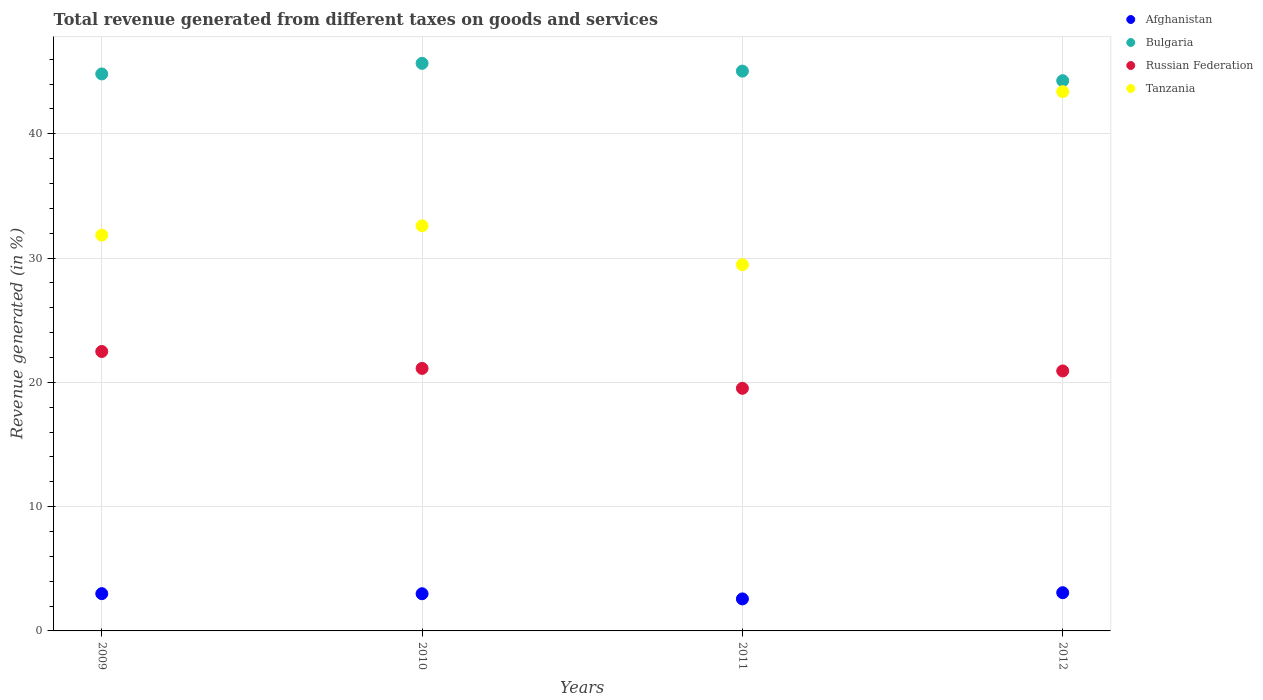Is the number of dotlines equal to the number of legend labels?
Provide a short and direct response. Yes. What is the total revenue generated in Russian Federation in 2010?
Your answer should be very brief. 21.12. Across all years, what is the maximum total revenue generated in Bulgaria?
Your response must be concise. 45.67. Across all years, what is the minimum total revenue generated in Russian Federation?
Provide a short and direct response. 19.52. In which year was the total revenue generated in Bulgaria maximum?
Your answer should be very brief. 2010. In which year was the total revenue generated in Tanzania minimum?
Ensure brevity in your answer.  2011. What is the total total revenue generated in Russian Federation in the graph?
Ensure brevity in your answer.  84.04. What is the difference between the total revenue generated in Afghanistan in 2010 and that in 2012?
Make the answer very short. -0.08. What is the difference between the total revenue generated in Russian Federation in 2011 and the total revenue generated in Tanzania in 2009?
Your answer should be compact. -12.33. What is the average total revenue generated in Russian Federation per year?
Provide a short and direct response. 21.01. In the year 2011, what is the difference between the total revenue generated in Tanzania and total revenue generated in Russian Federation?
Your response must be concise. 9.94. In how many years, is the total revenue generated in Bulgaria greater than 24 %?
Provide a succinct answer. 4. What is the ratio of the total revenue generated in Tanzania in 2010 to that in 2011?
Keep it short and to the point. 1.11. Is the difference between the total revenue generated in Tanzania in 2010 and 2011 greater than the difference between the total revenue generated in Russian Federation in 2010 and 2011?
Your response must be concise. Yes. What is the difference between the highest and the second highest total revenue generated in Tanzania?
Provide a succinct answer. 10.79. What is the difference between the highest and the lowest total revenue generated in Russian Federation?
Provide a succinct answer. 2.96. Is the sum of the total revenue generated in Tanzania in 2009 and 2011 greater than the maximum total revenue generated in Russian Federation across all years?
Ensure brevity in your answer.  Yes. Is it the case that in every year, the sum of the total revenue generated in Bulgaria and total revenue generated in Afghanistan  is greater than the sum of total revenue generated in Tanzania and total revenue generated in Russian Federation?
Your answer should be very brief. Yes. Is it the case that in every year, the sum of the total revenue generated in Bulgaria and total revenue generated in Russian Federation  is greater than the total revenue generated in Afghanistan?
Your response must be concise. Yes. Are the values on the major ticks of Y-axis written in scientific E-notation?
Offer a very short reply. No. Does the graph contain grids?
Offer a terse response. Yes. Where does the legend appear in the graph?
Provide a succinct answer. Top right. How are the legend labels stacked?
Give a very brief answer. Vertical. What is the title of the graph?
Give a very brief answer. Total revenue generated from different taxes on goods and services. What is the label or title of the Y-axis?
Your answer should be compact. Revenue generated (in %). What is the Revenue generated (in %) of Afghanistan in 2009?
Offer a very short reply. 3. What is the Revenue generated (in %) of Bulgaria in 2009?
Offer a very short reply. 44.81. What is the Revenue generated (in %) of Russian Federation in 2009?
Your answer should be compact. 22.48. What is the Revenue generated (in %) of Tanzania in 2009?
Provide a short and direct response. 31.85. What is the Revenue generated (in %) in Afghanistan in 2010?
Offer a very short reply. 2.99. What is the Revenue generated (in %) of Bulgaria in 2010?
Your response must be concise. 45.67. What is the Revenue generated (in %) in Russian Federation in 2010?
Provide a succinct answer. 21.12. What is the Revenue generated (in %) in Tanzania in 2010?
Your answer should be compact. 32.6. What is the Revenue generated (in %) in Afghanistan in 2011?
Provide a succinct answer. 2.58. What is the Revenue generated (in %) of Bulgaria in 2011?
Offer a terse response. 45.04. What is the Revenue generated (in %) in Russian Federation in 2011?
Provide a succinct answer. 19.52. What is the Revenue generated (in %) of Tanzania in 2011?
Give a very brief answer. 29.47. What is the Revenue generated (in %) of Afghanistan in 2012?
Your answer should be compact. 3.08. What is the Revenue generated (in %) in Bulgaria in 2012?
Provide a succinct answer. 44.27. What is the Revenue generated (in %) of Russian Federation in 2012?
Make the answer very short. 20.92. What is the Revenue generated (in %) of Tanzania in 2012?
Give a very brief answer. 43.39. Across all years, what is the maximum Revenue generated (in %) in Afghanistan?
Your response must be concise. 3.08. Across all years, what is the maximum Revenue generated (in %) of Bulgaria?
Your response must be concise. 45.67. Across all years, what is the maximum Revenue generated (in %) in Russian Federation?
Provide a short and direct response. 22.48. Across all years, what is the maximum Revenue generated (in %) in Tanzania?
Provide a short and direct response. 43.39. Across all years, what is the minimum Revenue generated (in %) of Afghanistan?
Make the answer very short. 2.58. Across all years, what is the minimum Revenue generated (in %) in Bulgaria?
Your answer should be compact. 44.27. Across all years, what is the minimum Revenue generated (in %) of Russian Federation?
Keep it short and to the point. 19.52. Across all years, what is the minimum Revenue generated (in %) in Tanzania?
Provide a succinct answer. 29.47. What is the total Revenue generated (in %) in Afghanistan in the graph?
Offer a terse response. 11.64. What is the total Revenue generated (in %) of Bulgaria in the graph?
Your answer should be very brief. 179.79. What is the total Revenue generated (in %) in Russian Federation in the graph?
Offer a very short reply. 84.04. What is the total Revenue generated (in %) in Tanzania in the graph?
Give a very brief answer. 137.3. What is the difference between the Revenue generated (in %) in Afghanistan in 2009 and that in 2010?
Give a very brief answer. 0.01. What is the difference between the Revenue generated (in %) in Bulgaria in 2009 and that in 2010?
Make the answer very short. -0.85. What is the difference between the Revenue generated (in %) in Russian Federation in 2009 and that in 2010?
Make the answer very short. 1.36. What is the difference between the Revenue generated (in %) in Tanzania in 2009 and that in 2010?
Your answer should be very brief. -0.75. What is the difference between the Revenue generated (in %) in Afghanistan in 2009 and that in 2011?
Give a very brief answer. 0.42. What is the difference between the Revenue generated (in %) of Bulgaria in 2009 and that in 2011?
Make the answer very short. -0.23. What is the difference between the Revenue generated (in %) of Russian Federation in 2009 and that in 2011?
Your answer should be compact. 2.96. What is the difference between the Revenue generated (in %) in Tanzania in 2009 and that in 2011?
Your answer should be very brief. 2.38. What is the difference between the Revenue generated (in %) in Afghanistan in 2009 and that in 2012?
Your response must be concise. -0.08. What is the difference between the Revenue generated (in %) of Bulgaria in 2009 and that in 2012?
Ensure brevity in your answer.  0.54. What is the difference between the Revenue generated (in %) of Russian Federation in 2009 and that in 2012?
Offer a very short reply. 1.56. What is the difference between the Revenue generated (in %) in Tanzania in 2009 and that in 2012?
Offer a terse response. -11.54. What is the difference between the Revenue generated (in %) of Afghanistan in 2010 and that in 2011?
Offer a terse response. 0.42. What is the difference between the Revenue generated (in %) of Bulgaria in 2010 and that in 2011?
Provide a short and direct response. 0.62. What is the difference between the Revenue generated (in %) of Russian Federation in 2010 and that in 2011?
Offer a terse response. 1.6. What is the difference between the Revenue generated (in %) of Tanzania in 2010 and that in 2011?
Make the answer very short. 3.13. What is the difference between the Revenue generated (in %) in Afghanistan in 2010 and that in 2012?
Offer a very short reply. -0.08. What is the difference between the Revenue generated (in %) of Bulgaria in 2010 and that in 2012?
Offer a very short reply. 1.4. What is the difference between the Revenue generated (in %) of Russian Federation in 2010 and that in 2012?
Give a very brief answer. 0.2. What is the difference between the Revenue generated (in %) in Tanzania in 2010 and that in 2012?
Offer a very short reply. -10.79. What is the difference between the Revenue generated (in %) in Afghanistan in 2011 and that in 2012?
Offer a terse response. -0.5. What is the difference between the Revenue generated (in %) in Bulgaria in 2011 and that in 2012?
Provide a succinct answer. 0.77. What is the difference between the Revenue generated (in %) of Russian Federation in 2011 and that in 2012?
Your answer should be compact. -1.4. What is the difference between the Revenue generated (in %) in Tanzania in 2011 and that in 2012?
Your answer should be very brief. -13.93. What is the difference between the Revenue generated (in %) of Afghanistan in 2009 and the Revenue generated (in %) of Bulgaria in 2010?
Ensure brevity in your answer.  -42.67. What is the difference between the Revenue generated (in %) in Afghanistan in 2009 and the Revenue generated (in %) in Russian Federation in 2010?
Your answer should be compact. -18.12. What is the difference between the Revenue generated (in %) of Afghanistan in 2009 and the Revenue generated (in %) of Tanzania in 2010?
Keep it short and to the point. -29.6. What is the difference between the Revenue generated (in %) in Bulgaria in 2009 and the Revenue generated (in %) in Russian Federation in 2010?
Your answer should be very brief. 23.69. What is the difference between the Revenue generated (in %) in Bulgaria in 2009 and the Revenue generated (in %) in Tanzania in 2010?
Offer a very short reply. 12.22. What is the difference between the Revenue generated (in %) of Russian Federation in 2009 and the Revenue generated (in %) of Tanzania in 2010?
Offer a terse response. -10.11. What is the difference between the Revenue generated (in %) of Afghanistan in 2009 and the Revenue generated (in %) of Bulgaria in 2011?
Keep it short and to the point. -42.04. What is the difference between the Revenue generated (in %) of Afghanistan in 2009 and the Revenue generated (in %) of Russian Federation in 2011?
Your answer should be compact. -16.52. What is the difference between the Revenue generated (in %) in Afghanistan in 2009 and the Revenue generated (in %) in Tanzania in 2011?
Offer a very short reply. -26.47. What is the difference between the Revenue generated (in %) in Bulgaria in 2009 and the Revenue generated (in %) in Russian Federation in 2011?
Keep it short and to the point. 25.29. What is the difference between the Revenue generated (in %) in Bulgaria in 2009 and the Revenue generated (in %) in Tanzania in 2011?
Offer a very short reply. 15.35. What is the difference between the Revenue generated (in %) in Russian Federation in 2009 and the Revenue generated (in %) in Tanzania in 2011?
Your response must be concise. -6.98. What is the difference between the Revenue generated (in %) in Afghanistan in 2009 and the Revenue generated (in %) in Bulgaria in 2012?
Offer a terse response. -41.27. What is the difference between the Revenue generated (in %) of Afghanistan in 2009 and the Revenue generated (in %) of Russian Federation in 2012?
Your response must be concise. -17.92. What is the difference between the Revenue generated (in %) of Afghanistan in 2009 and the Revenue generated (in %) of Tanzania in 2012?
Ensure brevity in your answer.  -40.39. What is the difference between the Revenue generated (in %) in Bulgaria in 2009 and the Revenue generated (in %) in Russian Federation in 2012?
Your answer should be very brief. 23.9. What is the difference between the Revenue generated (in %) in Bulgaria in 2009 and the Revenue generated (in %) in Tanzania in 2012?
Provide a short and direct response. 1.42. What is the difference between the Revenue generated (in %) of Russian Federation in 2009 and the Revenue generated (in %) of Tanzania in 2012?
Provide a succinct answer. -20.91. What is the difference between the Revenue generated (in %) in Afghanistan in 2010 and the Revenue generated (in %) in Bulgaria in 2011?
Give a very brief answer. -42.05. What is the difference between the Revenue generated (in %) of Afghanistan in 2010 and the Revenue generated (in %) of Russian Federation in 2011?
Keep it short and to the point. -16.53. What is the difference between the Revenue generated (in %) in Afghanistan in 2010 and the Revenue generated (in %) in Tanzania in 2011?
Make the answer very short. -26.47. What is the difference between the Revenue generated (in %) in Bulgaria in 2010 and the Revenue generated (in %) in Russian Federation in 2011?
Provide a short and direct response. 26.15. What is the difference between the Revenue generated (in %) in Bulgaria in 2010 and the Revenue generated (in %) in Tanzania in 2011?
Ensure brevity in your answer.  16.2. What is the difference between the Revenue generated (in %) of Russian Federation in 2010 and the Revenue generated (in %) of Tanzania in 2011?
Your response must be concise. -8.34. What is the difference between the Revenue generated (in %) in Afghanistan in 2010 and the Revenue generated (in %) in Bulgaria in 2012?
Make the answer very short. -41.28. What is the difference between the Revenue generated (in %) in Afghanistan in 2010 and the Revenue generated (in %) in Russian Federation in 2012?
Provide a short and direct response. -17.93. What is the difference between the Revenue generated (in %) in Afghanistan in 2010 and the Revenue generated (in %) in Tanzania in 2012?
Ensure brevity in your answer.  -40.4. What is the difference between the Revenue generated (in %) in Bulgaria in 2010 and the Revenue generated (in %) in Russian Federation in 2012?
Provide a succinct answer. 24.75. What is the difference between the Revenue generated (in %) in Bulgaria in 2010 and the Revenue generated (in %) in Tanzania in 2012?
Your answer should be very brief. 2.28. What is the difference between the Revenue generated (in %) of Russian Federation in 2010 and the Revenue generated (in %) of Tanzania in 2012?
Give a very brief answer. -22.27. What is the difference between the Revenue generated (in %) in Afghanistan in 2011 and the Revenue generated (in %) in Bulgaria in 2012?
Your answer should be very brief. -41.69. What is the difference between the Revenue generated (in %) in Afghanistan in 2011 and the Revenue generated (in %) in Russian Federation in 2012?
Offer a terse response. -18.34. What is the difference between the Revenue generated (in %) in Afghanistan in 2011 and the Revenue generated (in %) in Tanzania in 2012?
Offer a very short reply. -40.81. What is the difference between the Revenue generated (in %) in Bulgaria in 2011 and the Revenue generated (in %) in Russian Federation in 2012?
Your response must be concise. 24.12. What is the difference between the Revenue generated (in %) of Bulgaria in 2011 and the Revenue generated (in %) of Tanzania in 2012?
Ensure brevity in your answer.  1.65. What is the difference between the Revenue generated (in %) of Russian Federation in 2011 and the Revenue generated (in %) of Tanzania in 2012?
Ensure brevity in your answer.  -23.87. What is the average Revenue generated (in %) in Afghanistan per year?
Give a very brief answer. 2.91. What is the average Revenue generated (in %) of Bulgaria per year?
Make the answer very short. 44.95. What is the average Revenue generated (in %) in Russian Federation per year?
Your answer should be very brief. 21.01. What is the average Revenue generated (in %) of Tanzania per year?
Your response must be concise. 34.32. In the year 2009, what is the difference between the Revenue generated (in %) in Afghanistan and Revenue generated (in %) in Bulgaria?
Offer a terse response. -41.82. In the year 2009, what is the difference between the Revenue generated (in %) of Afghanistan and Revenue generated (in %) of Russian Federation?
Offer a terse response. -19.48. In the year 2009, what is the difference between the Revenue generated (in %) of Afghanistan and Revenue generated (in %) of Tanzania?
Provide a succinct answer. -28.85. In the year 2009, what is the difference between the Revenue generated (in %) of Bulgaria and Revenue generated (in %) of Russian Federation?
Give a very brief answer. 22.33. In the year 2009, what is the difference between the Revenue generated (in %) of Bulgaria and Revenue generated (in %) of Tanzania?
Offer a terse response. 12.97. In the year 2009, what is the difference between the Revenue generated (in %) of Russian Federation and Revenue generated (in %) of Tanzania?
Make the answer very short. -9.36. In the year 2010, what is the difference between the Revenue generated (in %) in Afghanistan and Revenue generated (in %) in Bulgaria?
Provide a short and direct response. -42.67. In the year 2010, what is the difference between the Revenue generated (in %) in Afghanistan and Revenue generated (in %) in Russian Federation?
Offer a very short reply. -18.13. In the year 2010, what is the difference between the Revenue generated (in %) in Afghanistan and Revenue generated (in %) in Tanzania?
Keep it short and to the point. -29.6. In the year 2010, what is the difference between the Revenue generated (in %) of Bulgaria and Revenue generated (in %) of Russian Federation?
Provide a short and direct response. 24.54. In the year 2010, what is the difference between the Revenue generated (in %) in Bulgaria and Revenue generated (in %) in Tanzania?
Give a very brief answer. 13.07. In the year 2010, what is the difference between the Revenue generated (in %) of Russian Federation and Revenue generated (in %) of Tanzania?
Make the answer very short. -11.47. In the year 2011, what is the difference between the Revenue generated (in %) of Afghanistan and Revenue generated (in %) of Bulgaria?
Keep it short and to the point. -42.47. In the year 2011, what is the difference between the Revenue generated (in %) in Afghanistan and Revenue generated (in %) in Russian Federation?
Your answer should be compact. -16.94. In the year 2011, what is the difference between the Revenue generated (in %) of Afghanistan and Revenue generated (in %) of Tanzania?
Ensure brevity in your answer.  -26.89. In the year 2011, what is the difference between the Revenue generated (in %) of Bulgaria and Revenue generated (in %) of Russian Federation?
Your response must be concise. 25.52. In the year 2011, what is the difference between the Revenue generated (in %) in Bulgaria and Revenue generated (in %) in Tanzania?
Keep it short and to the point. 15.58. In the year 2011, what is the difference between the Revenue generated (in %) of Russian Federation and Revenue generated (in %) of Tanzania?
Provide a succinct answer. -9.94. In the year 2012, what is the difference between the Revenue generated (in %) in Afghanistan and Revenue generated (in %) in Bulgaria?
Make the answer very short. -41.19. In the year 2012, what is the difference between the Revenue generated (in %) of Afghanistan and Revenue generated (in %) of Russian Federation?
Keep it short and to the point. -17.84. In the year 2012, what is the difference between the Revenue generated (in %) of Afghanistan and Revenue generated (in %) of Tanzania?
Your answer should be very brief. -40.31. In the year 2012, what is the difference between the Revenue generated (in %) of Bulgaria and Revenue generated (in %) of Russian Federation?
Your answer should be compact. 23.35. In the year 2012, what is the difference between the Revenue generated (in %) of Bulgaria and Revenue generated (in %) of Tanzania?
Provide a succinct answer. 0.88. In the year 2012, what is the difference between the Revenue generated (in %) of Russian Federation and Revenue generated (in %) of Tanzania?
Make the answer very short. -22.47. What is the ratio of the Revenue generated (in %) in Bulgaria in 2009 to that in 2010?
Your response must be concise. 0.98. What is the ratio of the Revenue generated (in %) of Russian Federation in 2009 to that in 2010?
Your answer should be very brief. 1.06. What is the ratio of the Revenue generated (in %) in Afghanistan in 2009 to that in 2011?
Make the answer very short. 1.16. What is the ratio of the Revenue generated (in %) in Russian Federation in 2009 to that in 2011?
Make the answer very short. 1.15. What is the ratio of the Revenue generated (in %) in Tanzania in 2009 to that in 2011?
Make the answer very short. 1.08. What is the ratio of the Revenue generated (in %) in Afghanistan in 2009 to that in 2012?
Give a very brief answer. 0.98. What is the ratio of the Revenue generated (in %) of Bulgaria in 2009 to that in 2012?
Offer a very short reply. 1.01. What is the ratio of the Revenue generated (in %) in Russian Federation in 2009 to that in 2012?
Make the answer very short. 1.07. What is the ratio of the Revenue generated (in %) in Tanzania in 2009 to that in 2012?
Your answer should be compact. 0.73. What is the ratio of the Revenue generated (in %) in Afghanistan in 2010 to that in 2011?
Your response must be concise. 1.16. What is the ratio of the Revenue generated (in %) in Bulgaria in 2010 to that in 2011?
Offer a terse response. 1.01. What is the ratio of the Revenue generated (in %) in Russian Federation in 2010 to that in 2011?
Keep it short and to the point. 1.08. What is the ratio of the Revenue generated (in %) of Tanzania in 2010 to that in 2011?
Give a very brief answer. 1.11. What is the ratio of the Revenue generated (in %) of Afghanistan in 2010 to that in 2012?
Keep it short and to the point. 0.97. What is the ratio of the Revenue generated (in %) in Bulgaria in 2010 to that in 2012?
Give a very brief answer. 1.03. What is the ratio of the Revenue generated (in %) in Russian Federation in 2010 to that in 2012?
Your response must be concise. 1.01. What is the ratio of the Revenue generated (in %) of Tanzania in 2010 to that in 2012?
Keep it short and to the point. 0.75. What is the ratio of the Revenue generated (in %) in Afghanistan in 2011 to that in 2012?
Offer a very short reply. 0.84. What is the ratio of the Revenue generated (in %) in Bulgaria in 2011 to that in 2012?
Your response must be concise. 1.02. What is the ratio of the Revenue generated (in %) of Russian Federation in 2011 to that in 2012?
Ensure brevity in your answer.  0.93. What is the ratio of the Revenue generated (in %) of Tanzania in 2011 to that in 2012?
Keep it short and to the point. 0.68. What is the difference between the highest and the second highest Revenue generated (in %) of Afghanistan?
Give a very brief answer. 0.08. What is the difference between the highest and the second highest Revenue generated (in %) of Bulgaria?
Make the answer very short. 0.62. What is the difference between the highest and the second highest Revenue generated (in %) in Russian Federation?
Provide a succinct answer. 1.36. What is the difference between the highest and the second highest Revenue generated (in %) in Tanzania?
Your answer should be compact. 10.79. What is the difference between the highest and the lowest Revenue generated (in %) of Afghanistan?
Give a very brief answer. 0.5. What is the difference between the highest and the lowest Revenue generated (in %) in Bulgaria?
Make the answer very short. 1.4. What is the difference between the highest and the lowest Revenue generated (in %) of Russian Federation?
Your answer should be compact. 2.96. What is the difference between the highest and the lowest Revenue generated (in %) of Tanzania?
Your answer should be very brief. 13.93. 